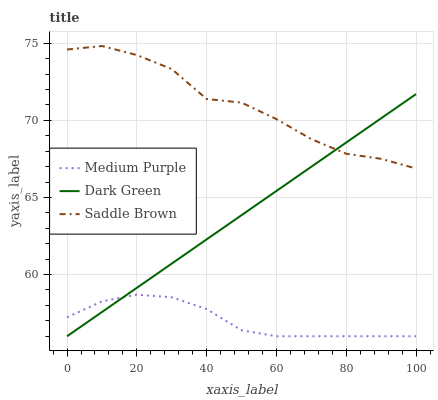Does Medium Purple have the minimum area under the curve?
Answer yes or no. Yes. Does Saddle Brown have the maximum area under the curve?
Answer yes or no. Yes. Does Dark Green have the minimum area under the curve?
Answer yes or no. No. Does Dark Green have the maximum area under the curve?
Answer yes or no. No. Is Dark Green the smoothest?
Answer yes or no. Yes. Is Saddle Brown the roughest?
Answer yes or no. Yes. Is Saddle Brown the smoothest?
Answer yes or no. No. Is Dark Green the roughest?
Answer yes or no. No. Does Medium Purple have the lowest value?
Answer yes or no. Yes. Does Saddle Brown have the lowest value?
Answer yes or no. No. Does Saddle Brown have the highest value?
Answer yes or no. Yes. Does Dark Green have the highest value?
Answer yes or no. No. Is Medium Purple less than Saddle Brown?
Answer yes or no. Yes. Is Saddle Brown greater than Medium Purple?
Answer yes or no. Yes. Does Saddle Brown intersect Dark Green?
Answer yes or no. Yes. Is Saddle Brown less than Dark Green?
Answer yes or no. No. Is Saddle Brown greater than Dark Green?
Answer yes or no. No. Does Medium Purple intersect Saddle Brown?
Answer yes or no. No. 